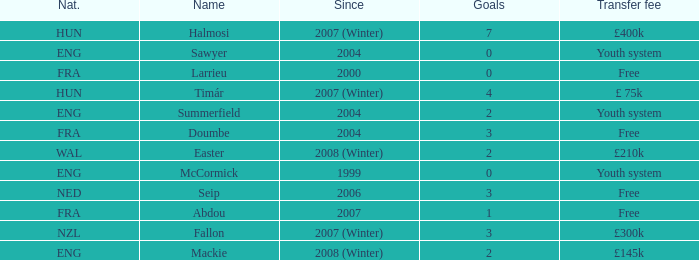What is the nationality of the player with a transfer fee of £400k? HUN. 